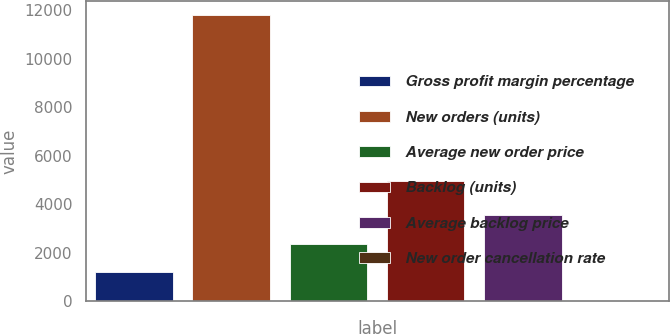Convert chart to OTSL. <chart><loc_0><loc_0><loc_500><loc_500><bar_chart><fcel>Gross profit margin percentage<fcel>New orders (units)<fcel>Average new order price<fcel>Backlog (units)<fcel>Average backlog price<fcel>New order cancellation rate<nl><fcel>1193.41<fcel>11800<fcel>2371.92<fcel>4945<fcel>3550.43<fcel>14.9<nl></chart> 